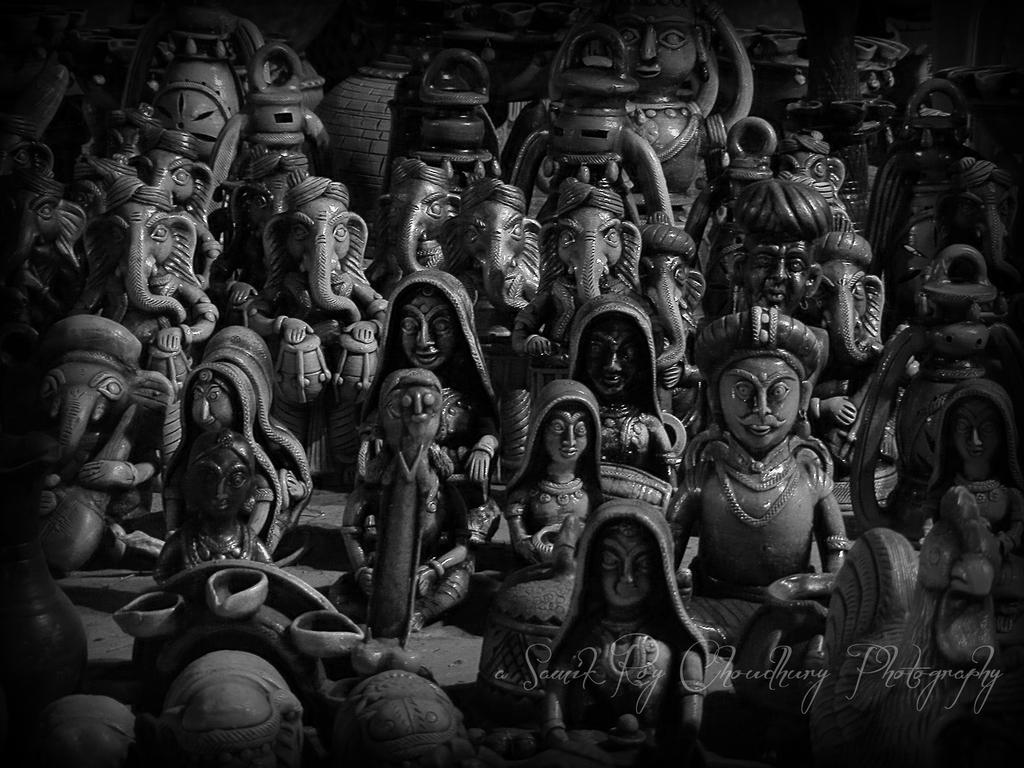What religious figures are depicted in the image? There are idols of Ganesha in the image. Who else is present in the image besides the idols? There are women and men in the image. What type of beast can be seen interacting with the idols in the image? There is no beast present in the image; it features idols of Ganesha and people. What type of pencil is being used by the women in the image? There is no pencil visible in the image, as it focuses on idols of Ganesha and people. 